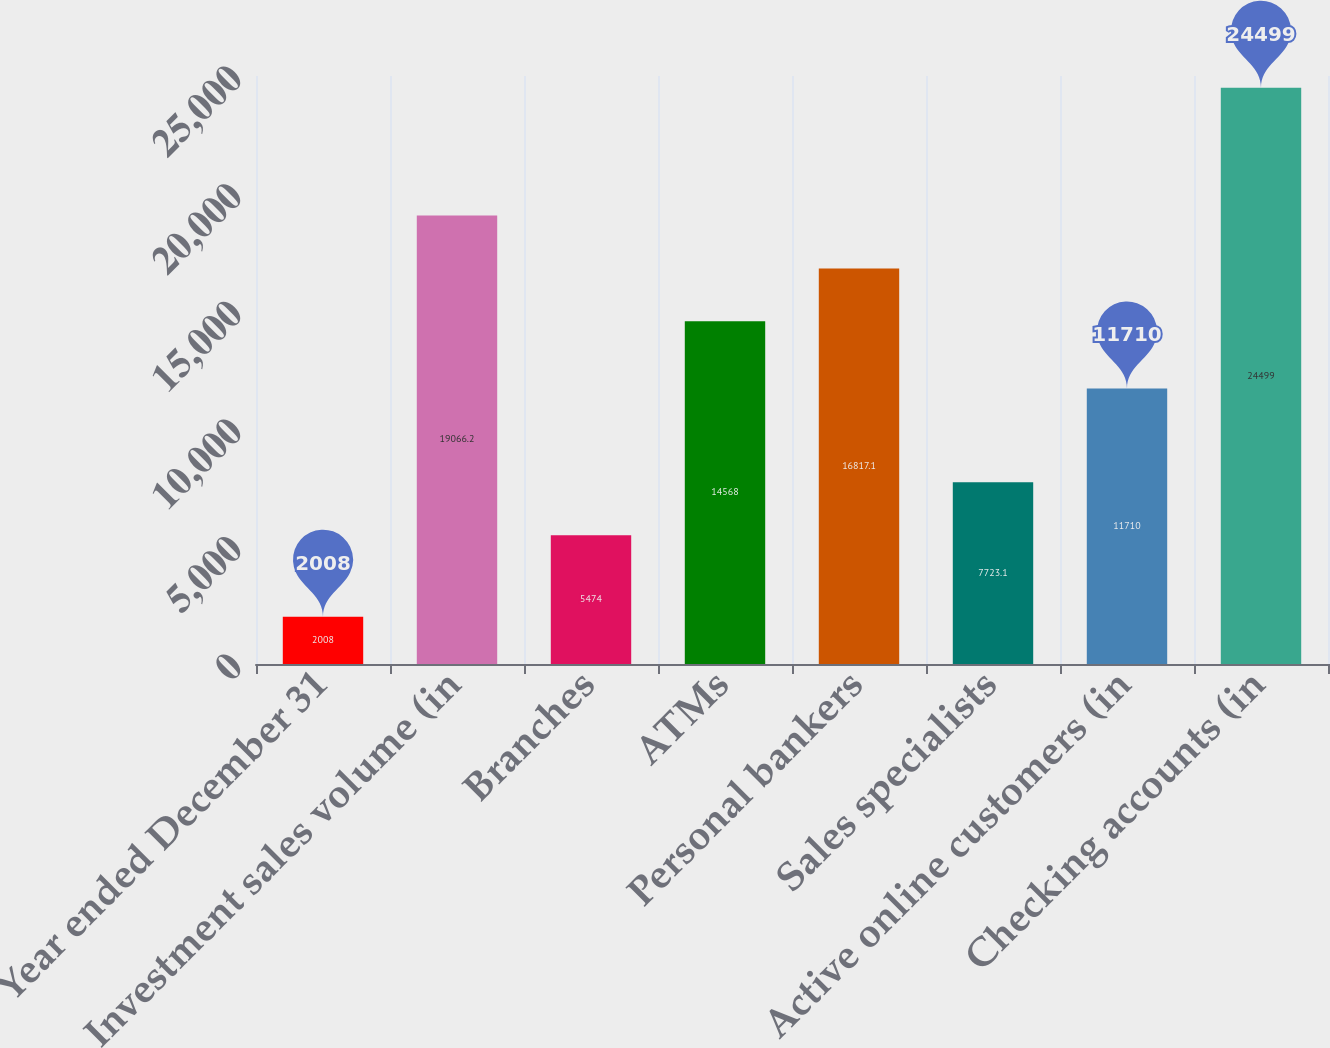<chart> <loc_0><loc_0><loc_500><loc_500><bar_chart><fcel>Year ended December 31<fcel>Investment sales volume (in<fcel>Branches<fcel>ATMs<fcel>Personal bankers<fcel>Sales specialists<fcel>Active online customers (in<fcel>Checking accounts (in<nl><fcel>2008<fcel>19066.2<fcel>5474<fcel>14568<fcel>16817.1<fcel>7723.1<fcel>11710<fcel>24499<nl></chart> 